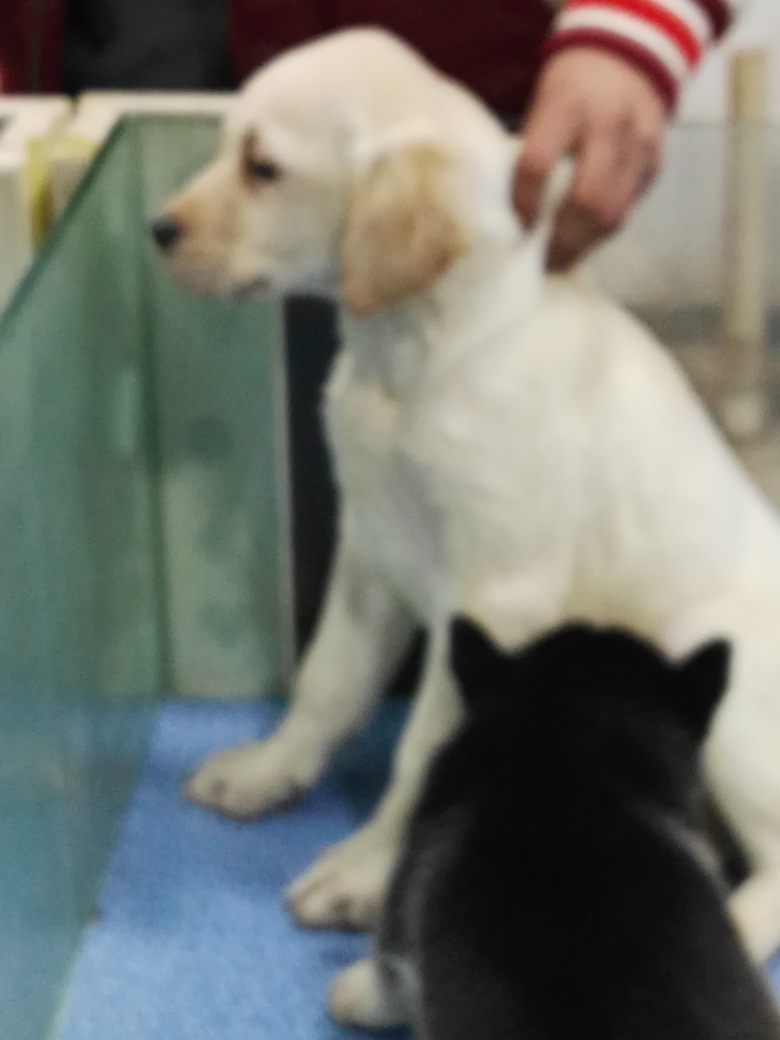What might be the reason for the dogs being there? Given the indoor environment and the presence of what looks like a partition, this could be a place where pets are cared for or trained, such as a vet clinic, a grooming salon, or a pet training center. The dogs might be there for a checkup, grooming, training session, or simply waiting to be picked up by their owners. 